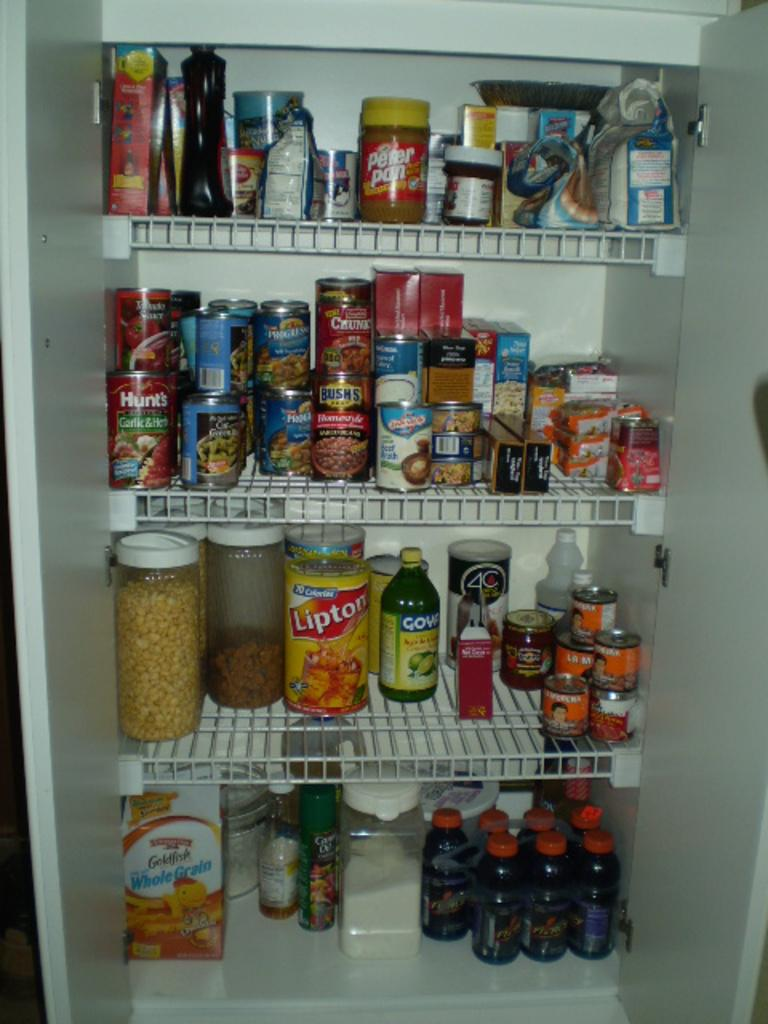<image>
Write a terse but informative summary of the picture. A pantry contains a can of Lipton iced tea mix and whole grain Goldfish. 